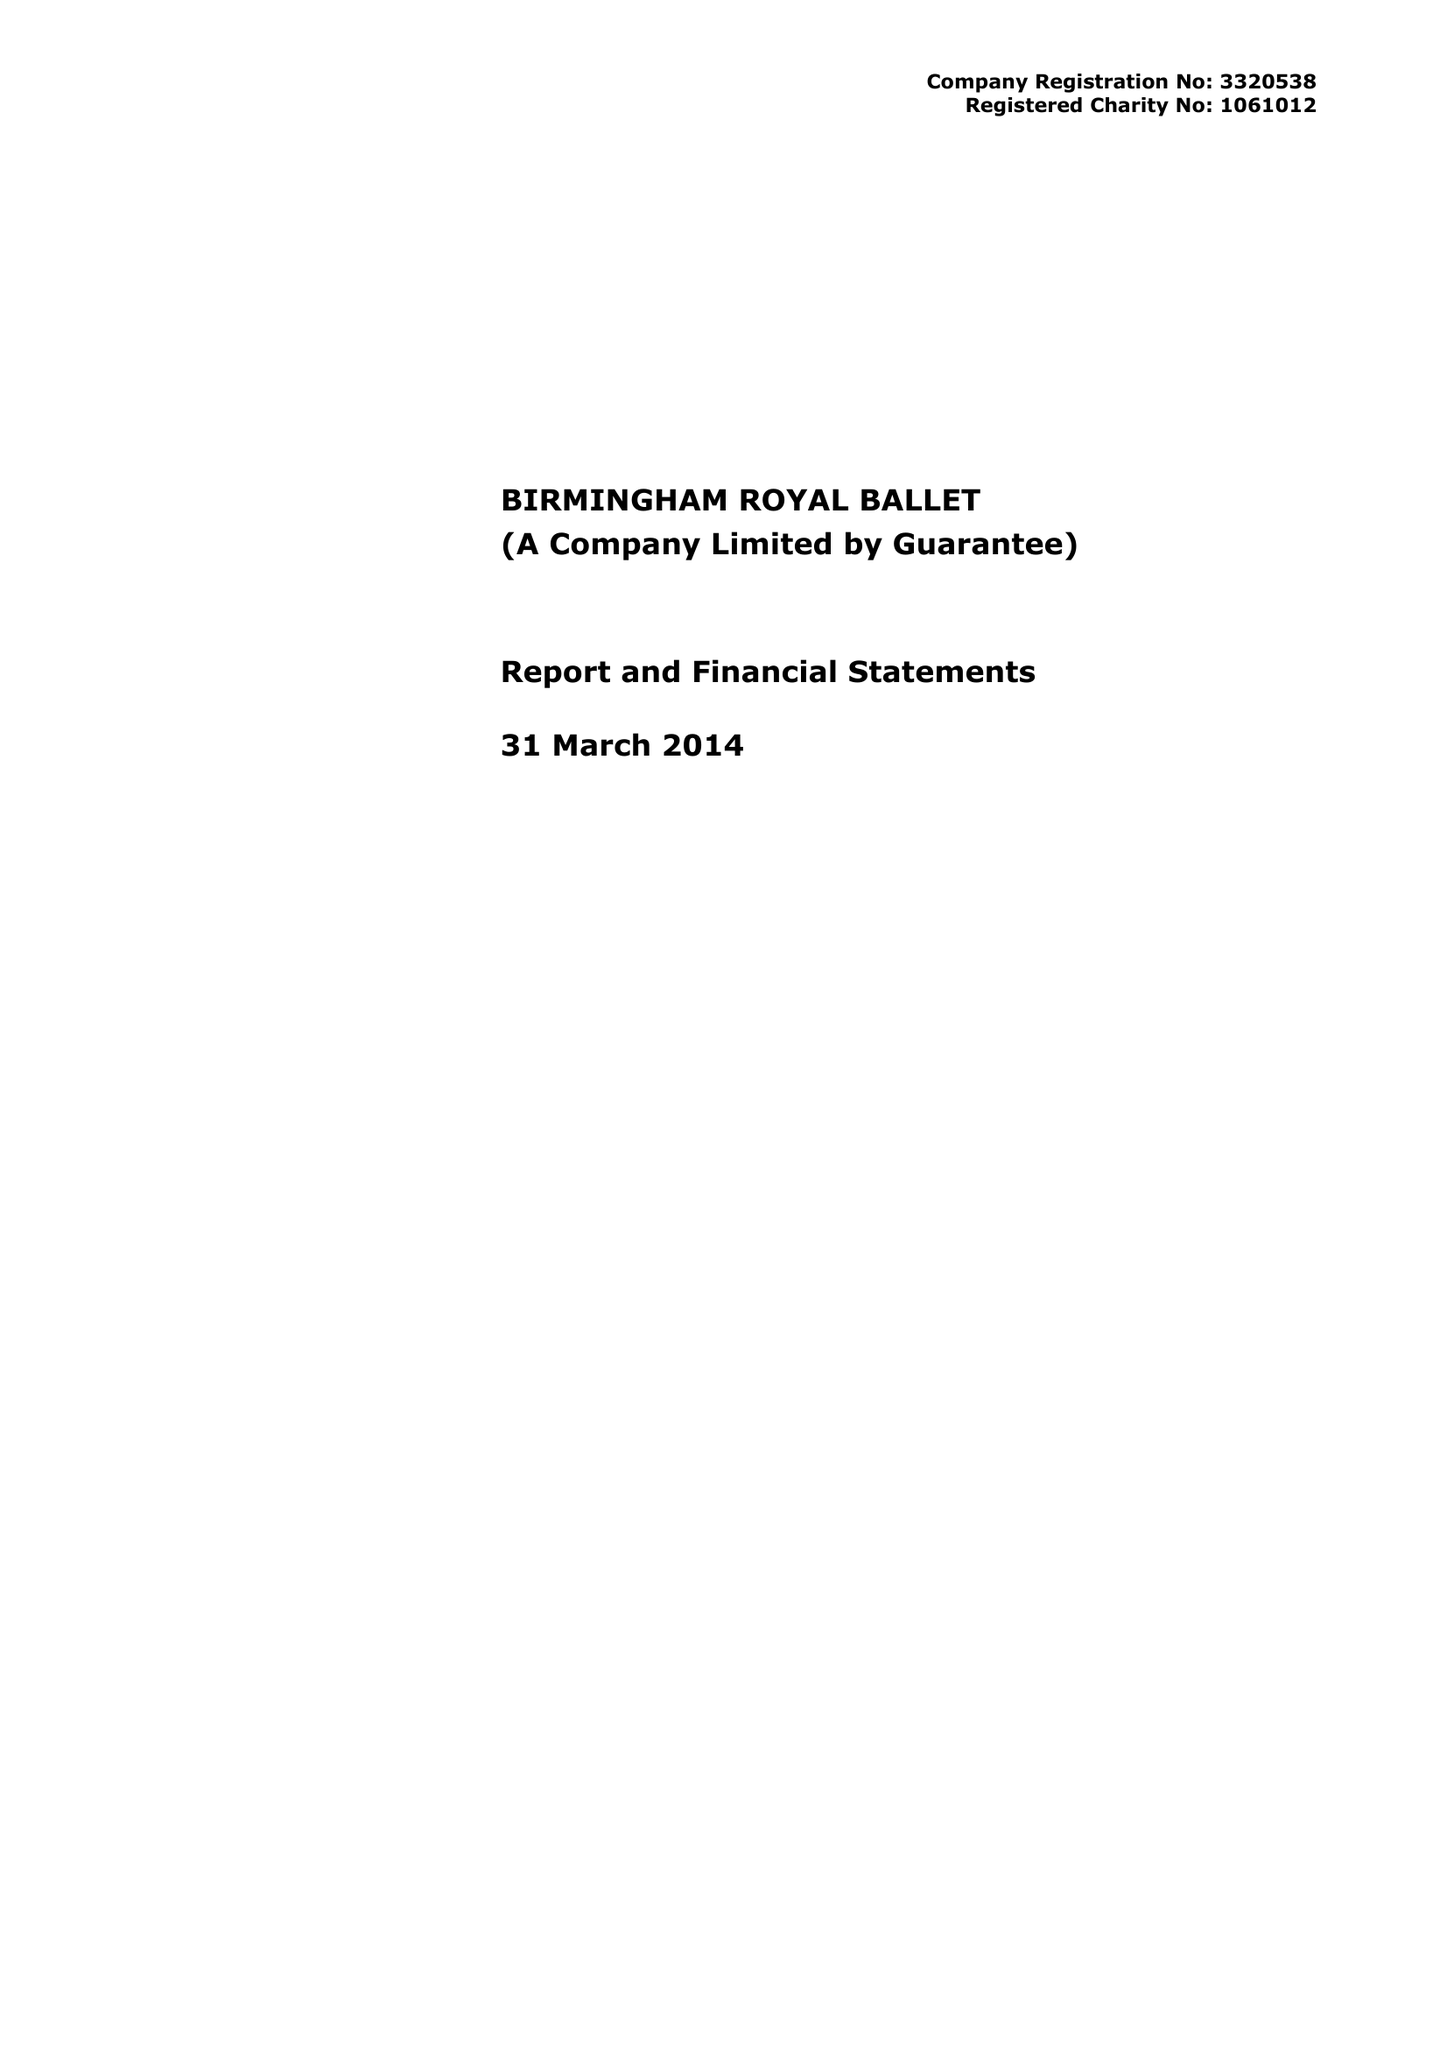What is the value for the address__postcode?
Answer the question using a single word or phrase. B5 4AU 